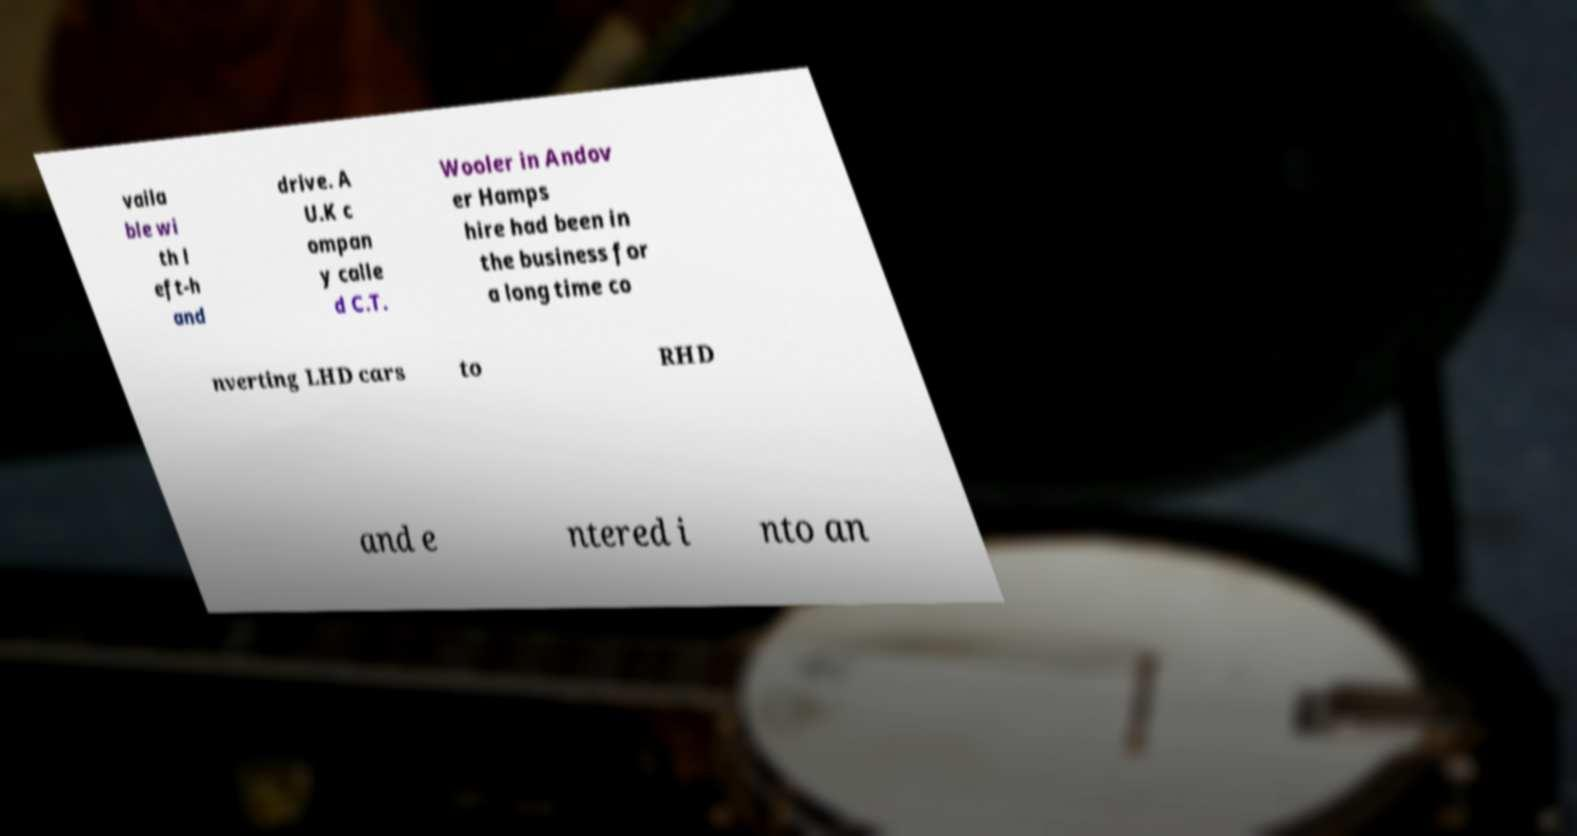Please read and relay the text visible in this image. What does it say? vaila ble wi th l eft-h and drive. A U.K c ompan y calle d C.T. Wooler in Andov er Hamps hire had been in the business for a long time co nverting LHD cars to RHD and e ntered i nto an 